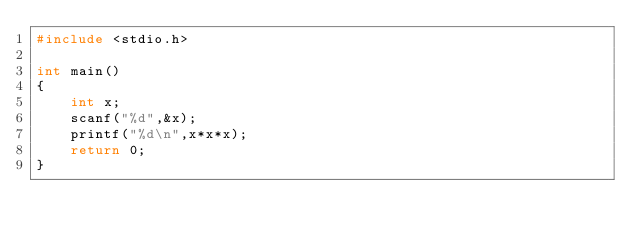<code> <loc_0><loc_0><loc_500><loc_500><_C_>#include <stdio.h>

int main()
{
    int x;
    scanf("%d",&x);
    printf("%d\n",x*x*x);
    return 0;
}</code> 